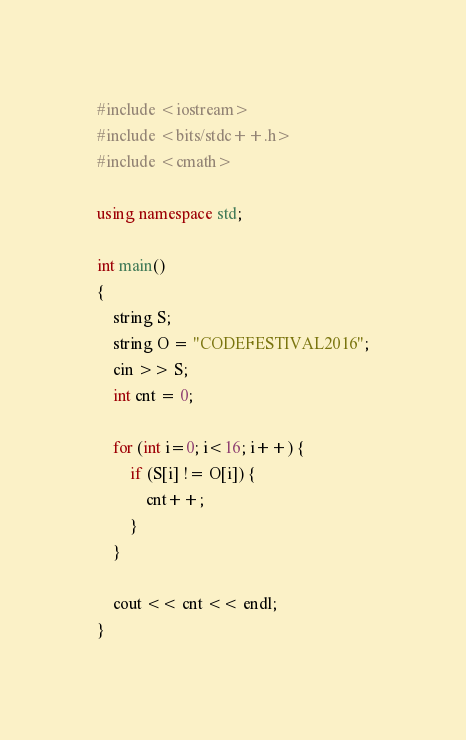Convert code to text. <code><loc_0><loc_0><loc_500><loc_500><_C++_>#include <iostream>
#include <bits/stdc++.h>
#include <cmath>

using namespace std;

int main()
{
    string S;
    string O = "CODEFESTIVAL2016";
    cin >> S;
    int cnt = 0;
    
    for (int i=0; i<16; i++) {
        if (S[i] != O[i]) {
            cnt++;
        }
    }
    
    cout << cnt << endl;
}</code> 